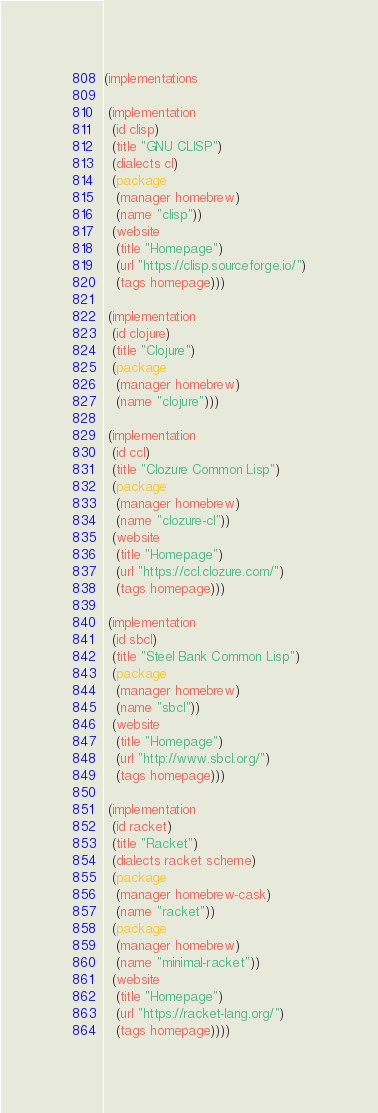<code> <loc_0><loc_0><loc_500><loc_500><_Lisp_>(implementations

 (implementation
  (id clisp)
  (title "GNU CLISP")
  (dialects cl)
  (package
   (manager homebrew)
   (name "clisp"))
  (website
   (title "Homepage")
   (url "https://clisp.sourceforge.io/")
   (tags homepage)))

 (implementation
  (id clojure)
  (title "Clojure")
  (package
   (manager homebrew)
   (name "clojure")))

 (implementation
  (id ccl)
  (title "Clozure Common Lisp")
  (package
   (manager homebrew)
   (name "clozure-cl"))
  (website
   (title "Homepage")
   (url "https://ccl.clozure.com/")
   (tags homepage)))

 (implementation
  (id sbcl)
  (title "Steel Bank Common Lisp")
  (package
   (manager homebrew)
   (name "sbcl"))
  (website
   (title "Homepage")
   (url "http://www.sbcl.org/")
   (tags homepage)))

 (implementation
  (id racket)
  (title "Racket")
  (dialects racket scheme)
  (package
   (manager homebrew-cask)
   (name "racket"))
  (package
   (manager homebrew)
   (name "minimal-racket"))
  (website
   (title "Homepage")
   (url "https://racket-lang.org/")
   (tags homepage))))
</code> 